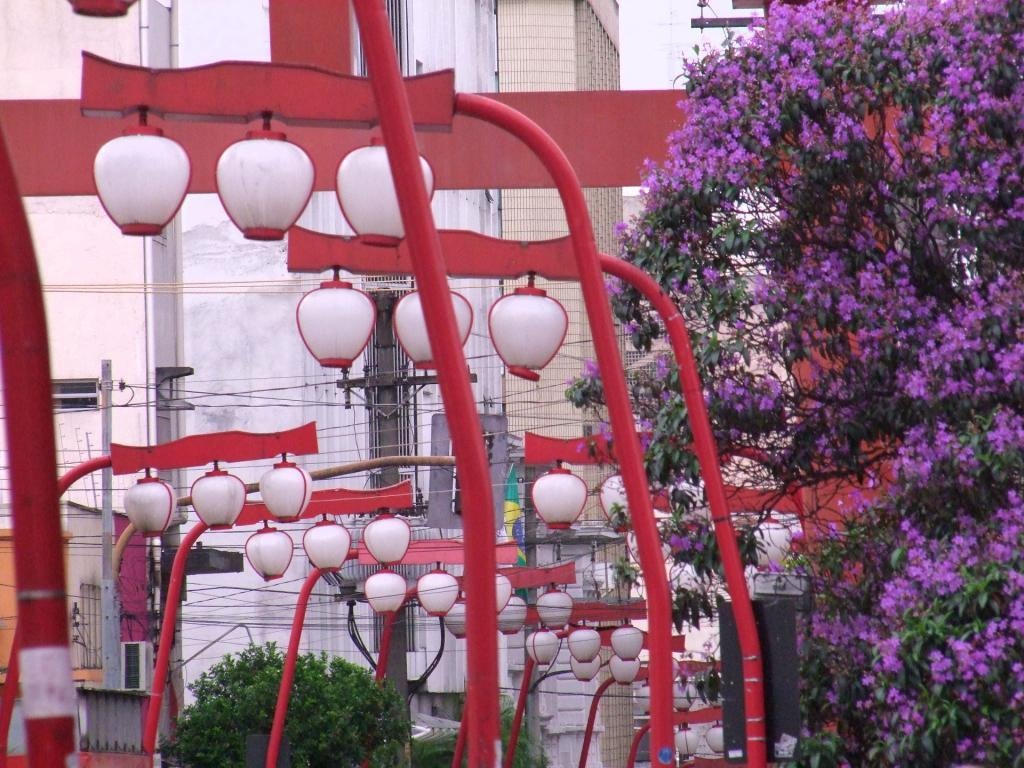What structures can be seen in the image? There are light poles in the image. What can be seen in the distance in the image? There are buildings and trees in the background of the image. What other objects can be seen in the background of the image? There are current poles in the background of the image. What is visible at the top of the image? The sky is visible at the top of the image. Can you see an owl perched on one of the light poles in the image? There is no owl present in the image; it only features light poles, buildings, trees, current poles, and the sky. Are there any people in the image kissing each other? There are no people visible in the image, let alone any who might be kissing. 